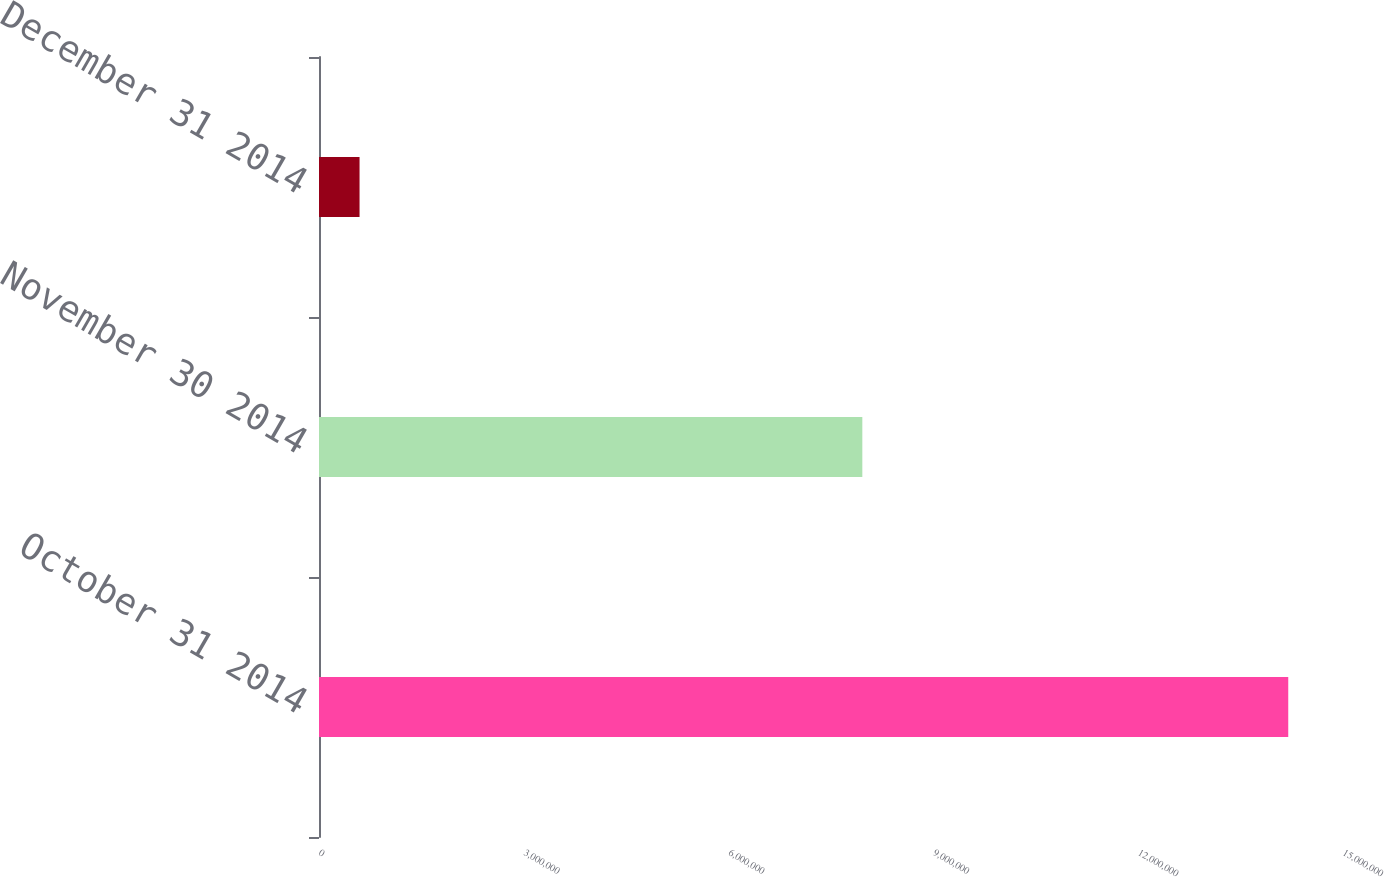Convert chart to OTSL. <chart><loc_0><loc_0><loc_500><loc_500><bar_chart><fcel>October 31 2014<fcel>November 30 2014<fcel>December 31 2014<nl><fcel>1.4198e+07<fcel>7.9589e+06<fcel>594056<nl></chart> 